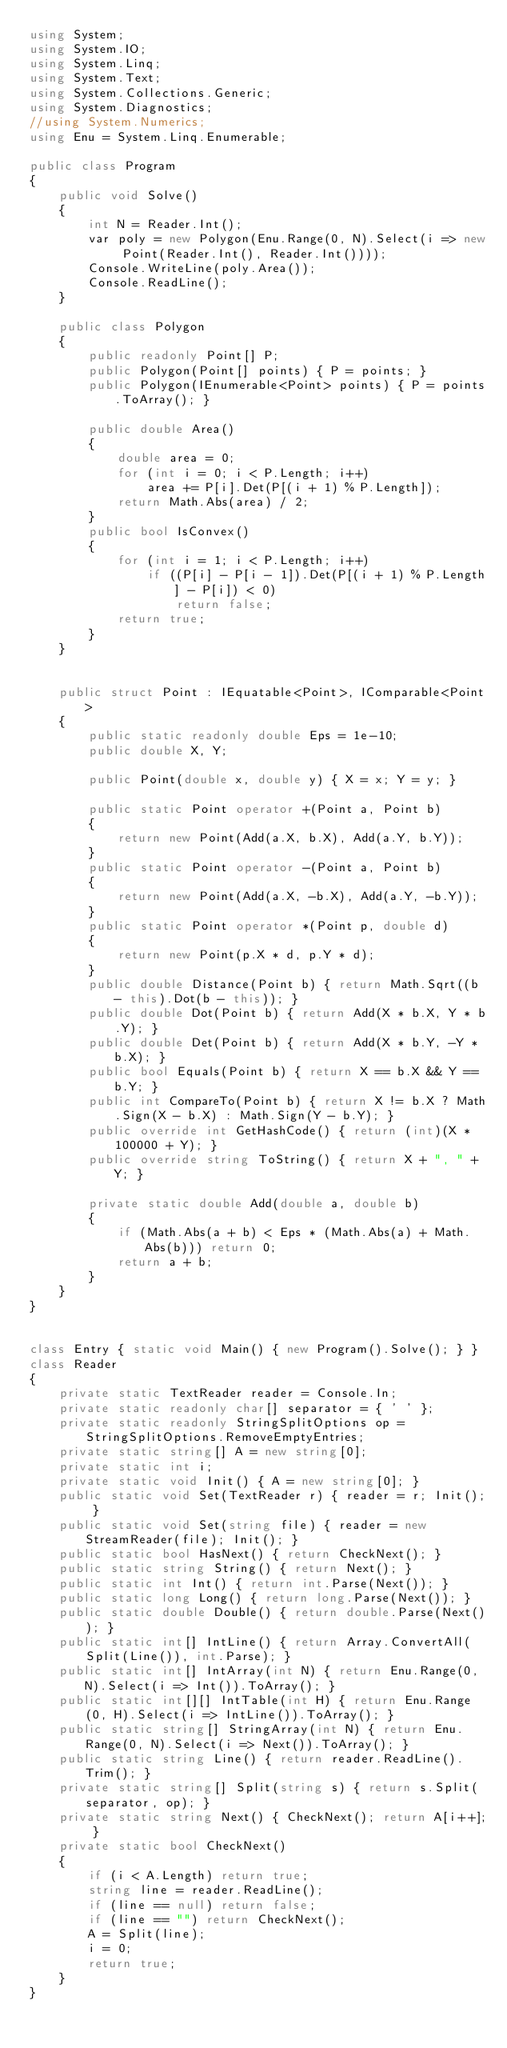Convert code to text. <code><loc_0><loc_0><loc_500><loc_500><_C#_>using System;
using System.IO;
using System.Linq;
using System.Text;
using System.Collections.Generic;
using System.Diagnostics;
//using System.Numerics;
using Enu = System.Linq.Enumerable;

public class Program
{
    public void Solve()
    {
        int N = Reader.Int();
        var poly = new Polygon(Enu.Range(0, N).Select(i => new Point(Reader.Int(), Reader.Int())));
        Console.WriteLine(poly.Area());
        Console.ReadLine();
    }

    public class Polygon
    {
        public readonly Point[] P;
        public Polygon(Point[] points) { P = points; }
        public Polygon(IEnumerable<Point> points) { P = points.ToArray(); }

        public double Area()
        {
            double area = 0;
            for (int i = 0; i < P.Length; i++)
                area += P[i].Det(P[(i + 1) % P.Length]);
            return Math.Abs(area) / 2;
        }
        public bool IsConvex()
        {
            for (int i = 1; i < P.Length; i++)
                if ((P[i] - P[i - 1]).Det(P[(i + 1) % P.Length] - P[i]) < 0)
                    return false;
            return true;
        }
    }


    public struct Point : IEquatable<Point>, IComparable<Point>
    {
        public static readonly double Eps = 1e-10;
        public double X, Y;

        public Point(double x, double y) { X = x; Y = y; }

        public static Point operator +(Point a, Point b)
        {
            return new Point(Add(a.X, b.X), Add(a.Y, b.Y));
        }
        public static Point operator -(Point a, Point b)
        {
            return new Point(Add(a.X, -b.X), Add(a.Y, -b.Y));
        }
        public static Point operator *(Point p, double d)
        {
            return new Point(p.X * d, p.Y * d);
        }
        public double Distance(Point b) { return Math.Sqrt((b - this).Dot(b - this)); }
        public double Dot(Point b) { return Add(X * b.X, Y * b.Y); }
        public double Det(Point b) { return Add(X * b.Y, -Y * b.X); }
        public bool Equals(Point b) { return X == b.X && Y == b.Y; }
        public int CompareTo(Point b) { return X != b.X ? Math.Sign(X - b.X) : Math.Sign(Y - b.Y); }
        public override int GetHashCode() { return (int)(X * 100000 + Y); }
        public override string ToString() { return X + ", " + Y; }

        private static double Add(double a, double b)
        {
            if (Math.Abs(a + b) < Eps * (Math.Abs(a) + Math.Abs(b))) return 0;
            return a + b;
        }
    }
}


class Entry { static void Main() { new Program().Solve(); } }
class Reader
{
    private static TextReader reader = Console.In;
    private static readonly char[] separator = { ' ' };
    private static readonly StringSplitOptions op = StringSplitOptions.RemoveEmptyEntries;
    private static string[] A = new string[0];
    private static int i;
    private static void Init() { A = new string[0]; }
    public static void Set(TextReader r) { reader = r; Init(); }
    public static void Set(string file) { reader = new StreamReader(file); Init(); }
    public static bool HasNext() { return CheckNext(); }
    public static string String() { return Next(); }
    public static int Int() { return int.Parse(Next()); }
    public static long Long() { return long.Parse(Next()); }
    public static double Double() { return double.Parse(Next()); }
    public static int[] IntLine() { return Array.ConvertAll(Split(Line()), int.Parse); }
    public static int[] IntArray(int N) { return Enu.Range(0, N).Select(i => Int()).ToArray(); }
    public static int[][] IntTable(int H) { return Enu.Range(0, H).Select(i => IntLine()).ToArray(); }
    public static string[] StringArray(int N) { return Enu.Range(0, N).Select(i => Next()).ToArray(); }
    public static string Line() { return reader.ReadLine().Trim(); }
    private static string[] Split(string s) { return s.Split(separator, op); }
    private static string Next() { CheckNext(); return A[i++]; }
    private static bool CheckNext()
    {
        if (i < A.Length) return true;
        string line = reader.ReadLine();
        if (line == null) return false;
        if (line == "") return CheckNext();
        A = Split(line);
        i = 0;
        return true;
    }
}</code> 